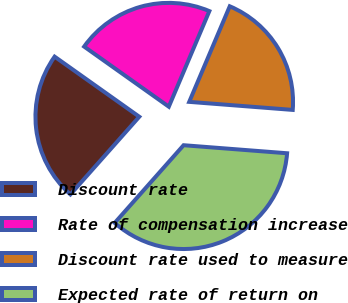Convert chart to OTSL. <chart><loc_0><loc_0><loc_500><loc_500><pie_chart><fcel>Discount rate<fcel>Rate of compensation increase<fcel>Discount rate used to measure<fcel>Expected rate of return on<nl><fcel>23.28%<fcel>21.56%<fcel>19.85%<fcel>35.31%<nl></chart> 